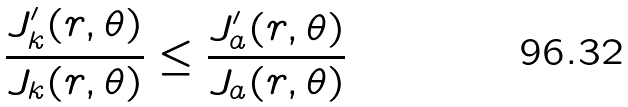<formula> <loc_0><loc_0><loc_500><loc_500>\frac { J _ { k } ^ { \prime } ( r , \theta ) } { J _ { k } ( r , \theta ) } \leq \frac { J _ { a } ^ { \prime } ( r , \theta ) } { J _ { a } ( r , \theta ) }</formula> 